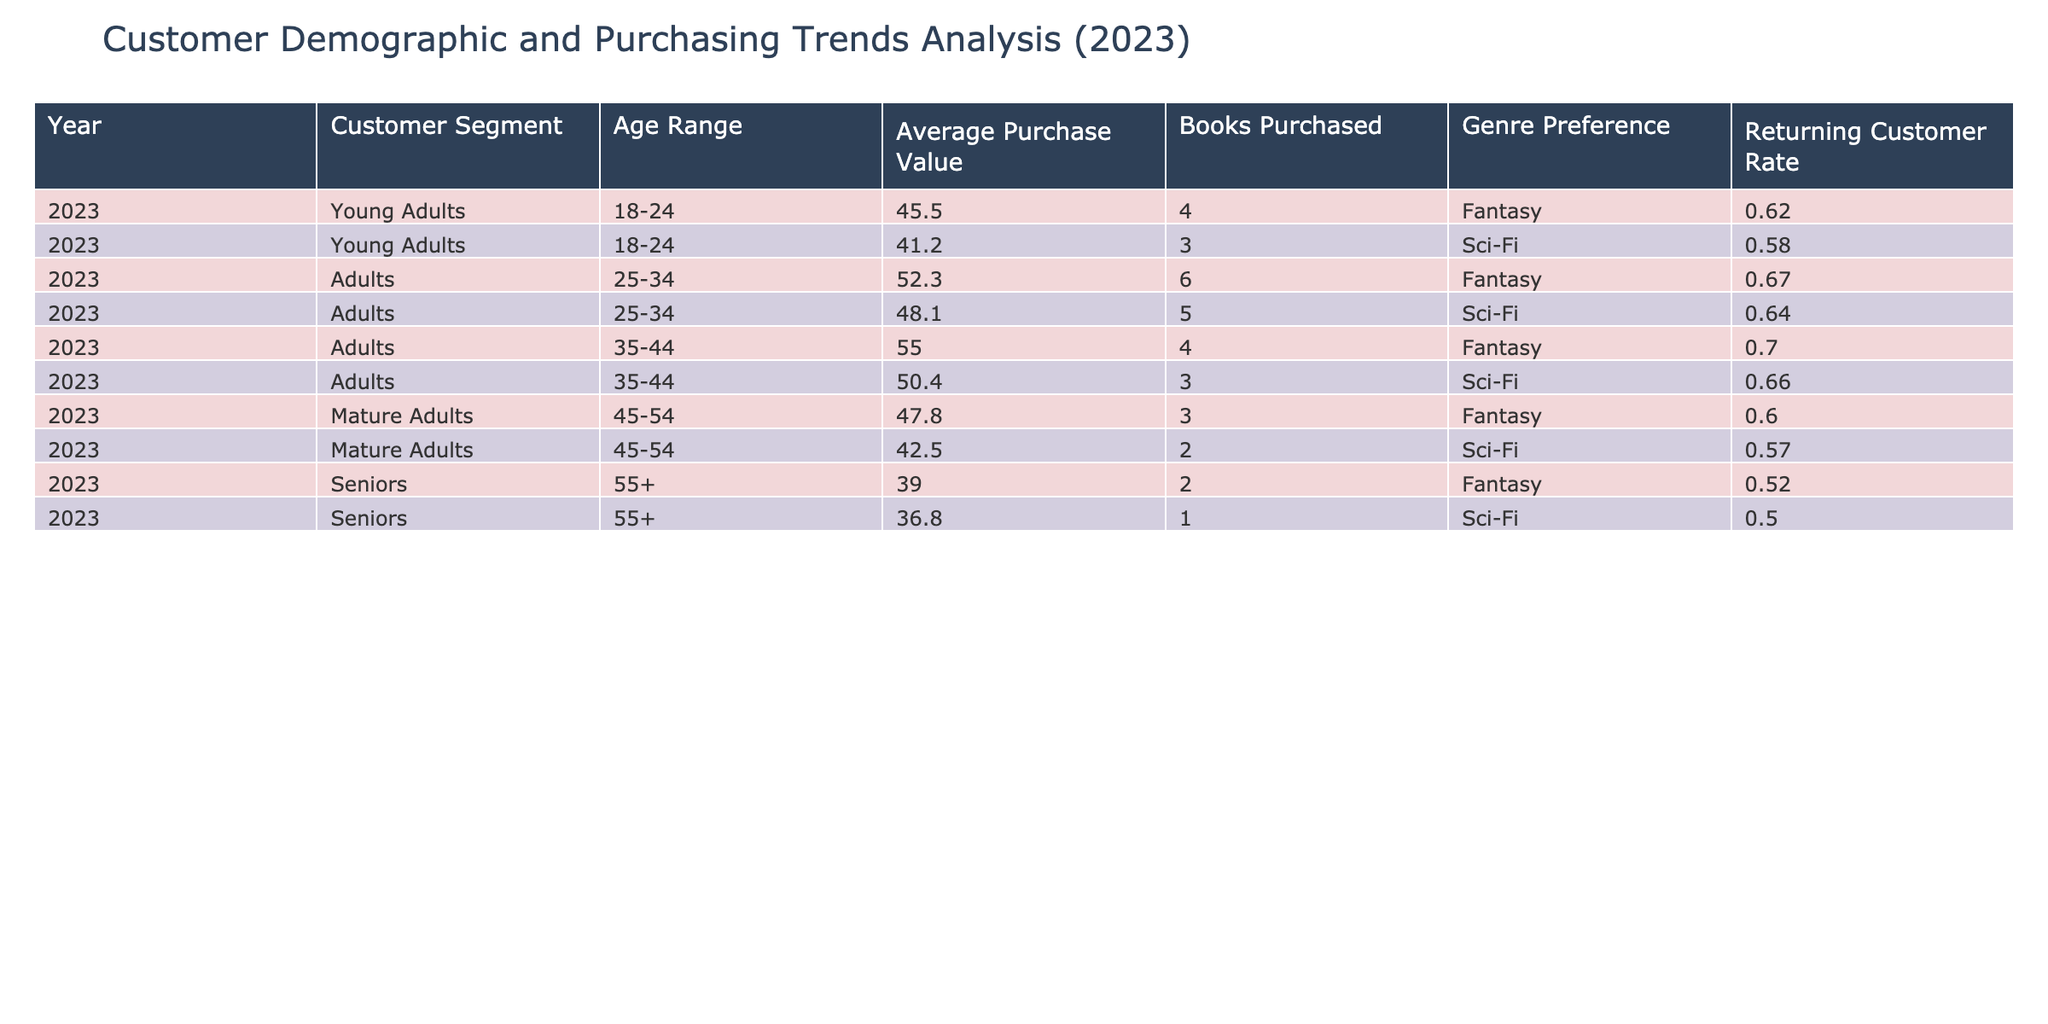What is the average purchase value for the age range 25-34? To find the average purchase value for the age range 25-34, we first identify the two entries corresponding to this age group: 52.30 and 48.10. Adding these amounts gives us 52.30 + 48.10 = 100.40. Since there are two entries, we divide by 2 to get the average: 100.40 / 2 = 50.20.
Answer: 50.20 Which customer segment has the highest returning customer rate? By examining the table, the returning customer rates for each segment are: Young Adults (0.62), Adults (0.67 for 25-34 and 0.70 for 35-44), Mature Adults (0.60), and Seniors (0.52). The highest returning customer rate is 0.70, which corresponds to the Adults in the age range 35-44.
Answer: Adults (35-44) How many books do returning Young Adults purchase on average? For the Young Adults, the total number of books purchased is from the two entries: 4 and 3. We sum these to get 4 + 3 = 7. Since there are two entries, we calculate the average by dividing the total by 2: 7 / 2 = 3.5.
Answer: 3.5 Is there a difference in average purchase value between the Fantasy and Sci-Fi genres for the age range 45-54? For Mature Adults, the average purchase values are: 47.80 for Fantasy (3 books) and 42.50 for Sci-Fi (2 books). The difference in average purchase value is calculated by subtracting the two values: 47.80 - 42.50 = 5.30.
Answer: 5.30 What is the total number of books purchased by Seniors? There are two entries for Seniors: 2 books (Fantasy) and 1 book (Sci-Fi). Adding these together gives us a total: 2 + 1 = 3 books purchased by Seniors.
Answer: 3 